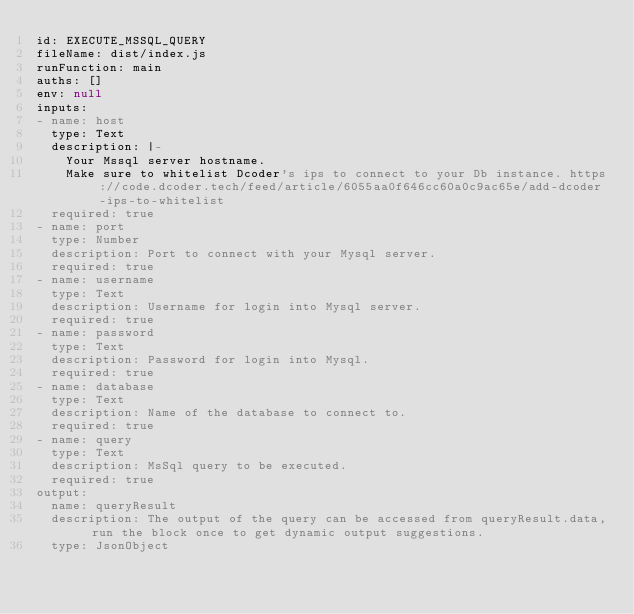<code> <loc_0><loc_0><loc_500><loc_500><_YAML_>id: EXECUTE_MSSQL_QUERY
fileName: dist/index.js
runFunction: main
auths: []
env: null
inputs:
- name: host
  type: Text
  description: |-
    Your Mssql server hostname.
    Make sure to whitelist Dcoder's ips to connect to your Db instance. https://code.dcoder.tech/feed/article/6055aa0f646cc60a0c9ac65e/add-dcoder-ips-to-whitelist
  required: true
- name: port
  type: Number
  description: Port to connect with your Mysql server.
  required: true
- name: username
  type: Text
  description: Username for login into Mysql server.
  required: true
- name: password
  type: Text
  description: Password for login into Mysql.
  required: true
- name: database
  type: Text
  description: Name of the database to connect to.
  required: true
- name: query
  type: Text
  description: MsSql query to be executed.
  required: true
output:
  name: queryResult
  description: The output of the query can be accessed from queryResult.data, run the block once to get dynamic output suggestions.
  type: JsonObject
</code> 